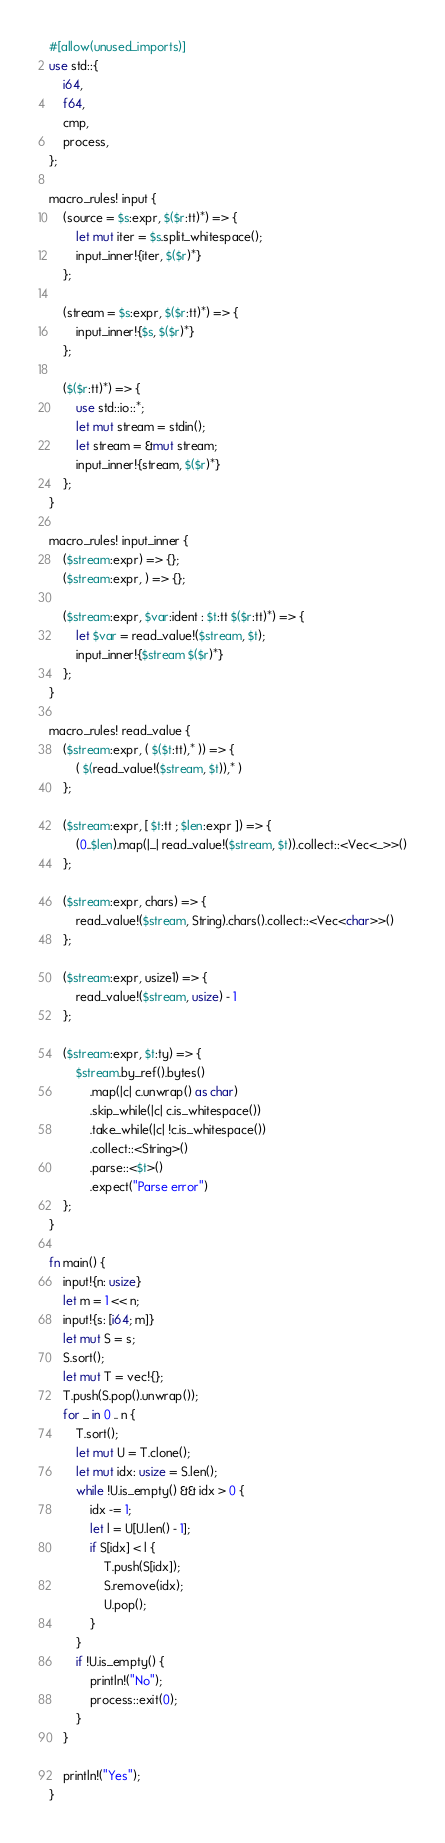<code> <loc_0><loc_0><loc_500><loc_500><_Rust_>#[allow(unused_imports)]
use std::{
    i64,
    f64,
    cmp,
    process,
};

macro_rules! input {
    (source = $s:expr, $($r:tt)*) => {
        let mut iter = $s.split_whitespace();
        input_inner!{iter, $($r)*}
    };

    (stream = $s:expr, $($r:tt)*) => {
        input_inner!{$s, $($r)*}
    };

    ($($r:tt)*) => {
        use std::io::*;
        let mut stream = stdin();
        let stream = &mut stream;
        input_inner!{stream, $($r)*}
    };
}

macro_rules! input_inner {
    ($stream:expr) => {};
    ($stream:expr, ) => {};

    ($stream:expr, $var:ident : $t:tt $($r:tt)*) => {
        let $var = read_value!($stream, $t);
        input_inner!{$stream $($r)*}
    };
}

macro_rules! read_value {
    ($stream:expr, ( $($t:tt),* )) => {
        ( $(read_value!($stream, $t)),* )
    };

    ($stream:expr, [ $t:tt ; $len:expr ]) => {
        (0..$len).map(|_| read_value!($stream, $t)).collect::<Vec<_>>()
    };

    ($stream:expr, chars) => {
        read_value!($stream, String).chars().collect::<Vec<char>>()
    };

    ($stream:expr, usize1) => {
        read_value!($stream, usize) - 1
    };

    ($stream:expr, $t:ty) => {
        $stream.by_ref().bytes()
            .map(|c| c.unwrap() as char)
            .skip_while(|c| c.is_whitespace())
            .take_while(|c| !c.is_whitespace())
            .collect::<String>()
            .parse::<$t>()
            .expect("Parse error")
    };
}

fn main() {
    input!{n: usize}
    let m = 1 << n;
    input!{s: [i64; m]}
    let mut S = s;
    S.sort();
    let mut T = vec!{};
    T.push(S.pop().unwrap());
    for _ in 0 .. n {
        T.sort();
        let mut U = T.clone();
        let mut idx: usize = S.len();
        while !U.is_empty() && idx > 0 {
            idx -= 1;
            let l = U[U.len() - 1];
            if S[idx] < l {
                T.push(S[idx]);
                S.remove(idx);
                U.pop();
            }
        }
        if !U.is_empty() {
            println!("No");
            process::exit(0);
        }
    }

    println!("Yes");
}</code> 